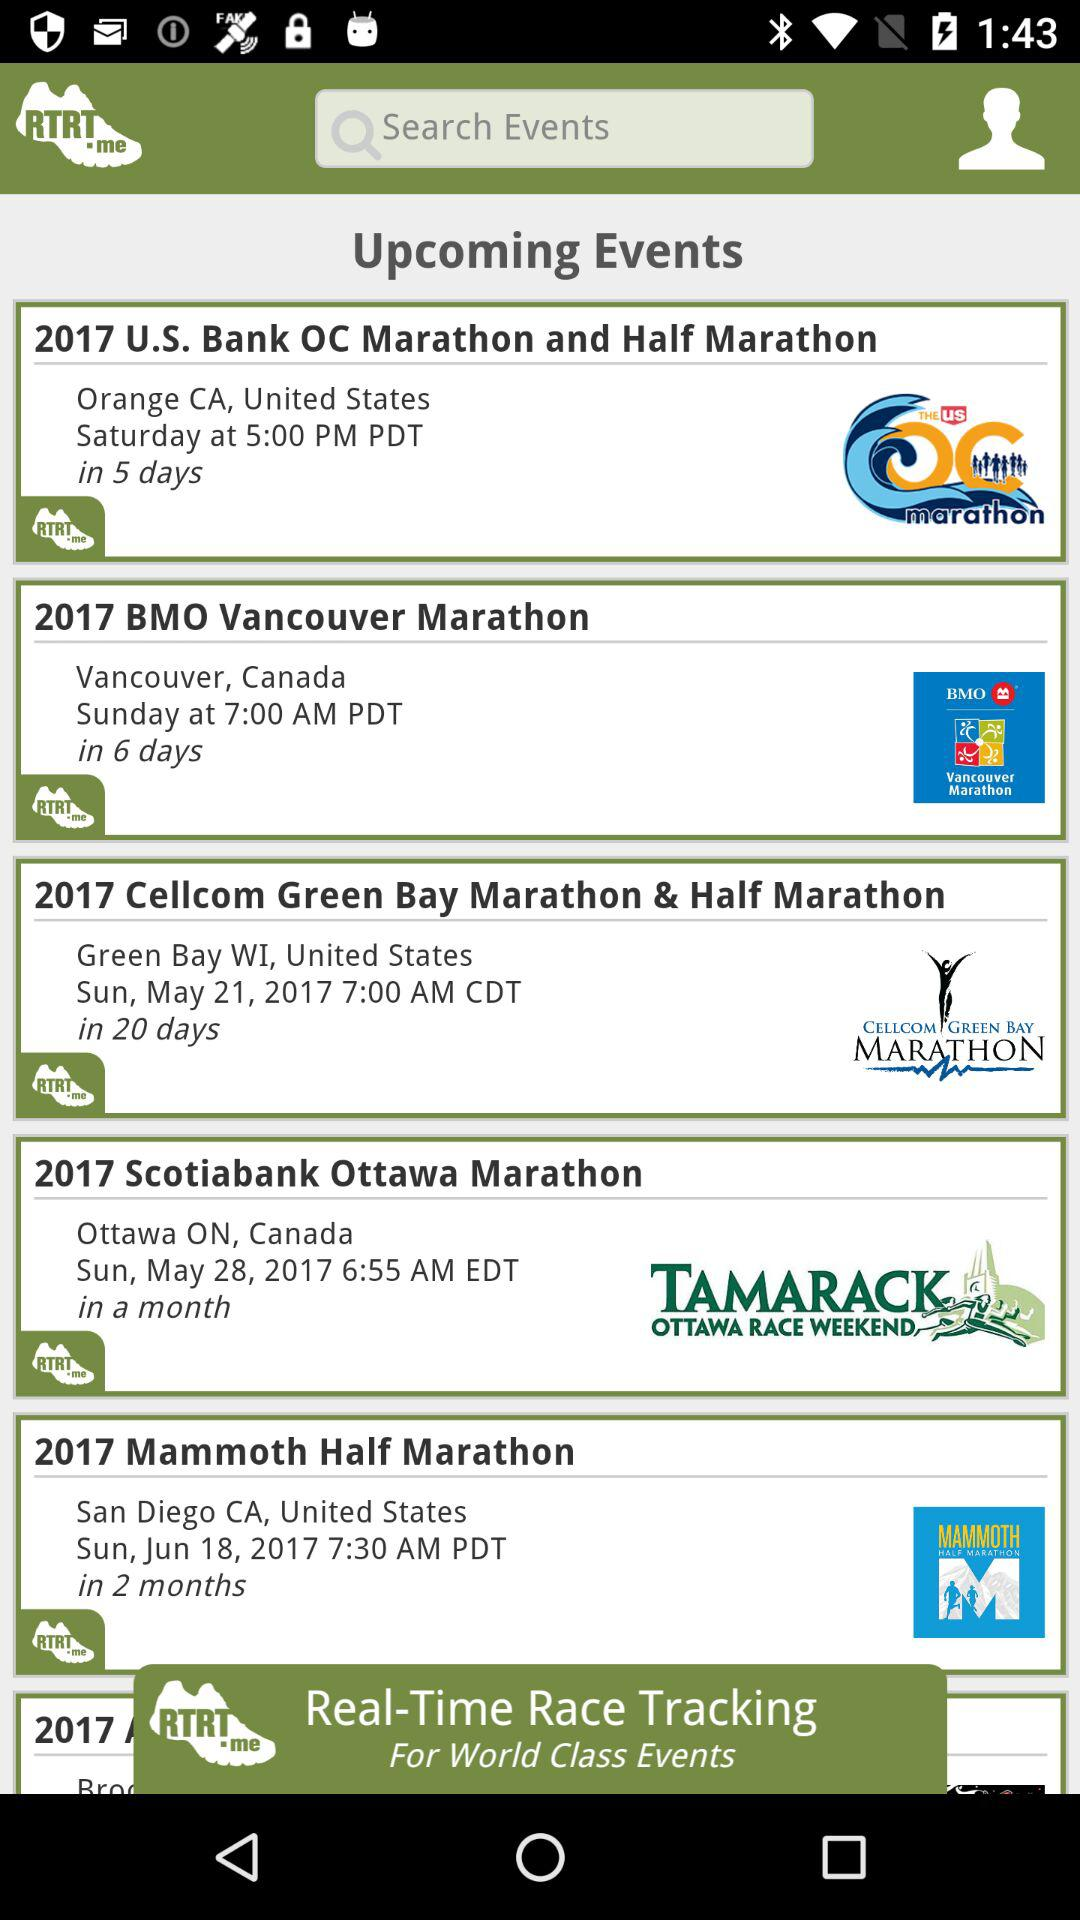How many events are there that are in Canada?
Answer the question using a single word or phrase. 2 